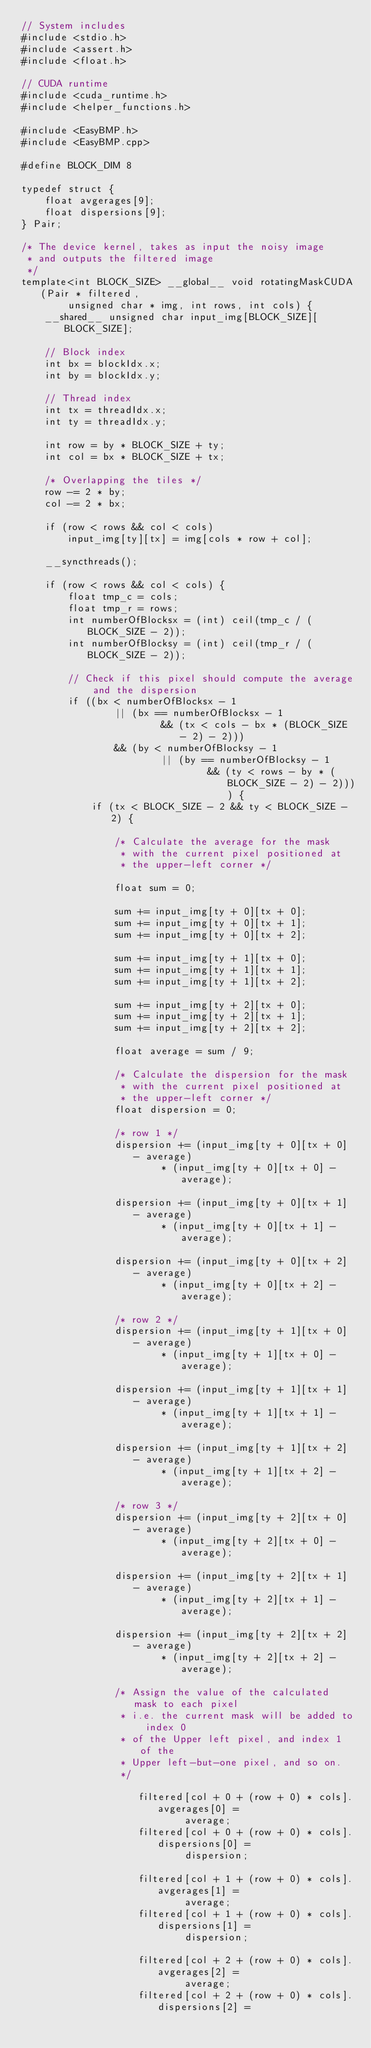<code> <loc_0><loc_0><loc_500><loc_500><_Cuda_>// System includes
#include <stdio.h>
#include <assert.h>
#include <float.h>

// CUDA runtime
#include <cuda_runtime.h>
#include <helper_functions.h>

#include <EasyBMP.h>
#include <EasyBMP.cpp>

#define BLOCK_DIM 8

typedef struct {
	float avgerages[9];
	float dispersions[9];
} Pair;

/* The device kernel, takes as input the noisy image
 * and outputs the filtered image
 */
template<int BLOCK_SIZE> __global__ void rotatingMaskCUDA(Pair * filtered,
		unsigned char * img, int rows, int cols) {
	__shared__ unsigned char input_img[BLOCK_SIZE][BLOCK_SIZE];

	// Block index
	int bx = blockIdx.x;
	int by = blockIdx.y;

	// Thread index
	int tx = threadIdx.x;
	int ty = threadIdx.y;

	int row = by * BLOCK_SIZE + ty;
	int col = bx * BLOCK_SIZE + tx;

	/* Overlapping the tiles */
	row -= 2 * by;
	col -= 2 * bx;

	if (row < rows && col < cols)
		input_img[ty][tx] = img[cols * row + col];

	__syncthreads();

	if (row < rows && col < cols) {
		float tmp_c = cols;
		float tmp_r = rows;
		int numberOfBlocksx = (int) ceil(tmp_c / (BLOCK_SIZE - 2));
		int numberOfBlocksy = (int) ceil(tmp_r / (BLOCK_SIZE - 2));

		// Check if this pixel should compute the average and the dispersion
		if ((bx < numberOfBlocksx - 1
				|| (bx == numberOfBlocksx - 1
						&& (tx < cols - bx * (BLOCK_SIZE - 2) - 2)))
				&& (by < numberOfBlocksy - 1
						|| (by == numberOfBlocksy - 1
								&& (ty < rows - by * (BLOCK_SIZE - 2) - 2)))) {
			if (tx < BLOCK_SIZE - 2 && ty < BLOCK_SIZE - 2) {

				/* Calculate the average for the mask
				 * with the current pixel positioned at
				 * the upper-left corner */

				float sum = 0;

				sum += input_img[ty + 0][tx + 0];
				sum += input_img[ty + 0][tx + 1];
				sum += input_img[ty + 0][tx + 2];

				sum += input_img[ty + 1][tx + 0];
				sum += input_img[ty + 1][tx + 1];
				sum += input_img[ty + 1][tx + 2];

				sum += input_img[ty + 2][tx + 0];
				sum += input_img[ty + 2][tx + 1];
				sum += input_img[ty + 2][tx + 2];

				float average = sum / 9;

				/* Calculate the dispersion for the mask
				 * with the current pixel positioned at
				 * the upper-left corner */
				float dispersion = 0;

				/* row 1 */
				dispersion += (input_img[ty + 0][tx + 0] - average)
						* (input_img[ty + 0][tx + 0] - average);

				dispersion += (input_img[ty + 0][tx + 1] - average)
						* (input_img[ty + 0][tx + 1] - average);

				dispersion += (input_img[ty + 0][tx + 2] - average)
						* (input_img[ty + 0][tx + 2] - average);

				/* row 2 */
				dispersion += (input_img[ty + 1][tx + 0] - average)
						* (input_img[ty + 1][tx + 0] - average);

				dispersion += (input_img[ty + 1][tx + 1] - average)
						* (input_img[ty + 1][tx + 1] - average);

				dispersion += (input_img[ty + 1][tx + 2] - average)
						* (input_img[ty + 1][tx + 2] - average);

				/* row 3 */
				dispersion += (input_img[ty + 2][tx + 0] - average)
						* (input_img[ty + 2][tx + 0] - average);

				dispersion += (input_img[ty + 2][tx + 1] - average)
						* (input_img[ty + 2][tx + 1] - average);

				dispersion += (input_img[ty + 2][tx + 2] - average)
						* (input_img[ty + 2][tx + 2] - average);

				/* Assign the value of the calculated mask to each pixel
				 * i.e. the current mask will be added to index 0
				 * of the Upper left pixel, and index 1 of the
				 * Upper left-but-one pixel, and so on.
				 */

					filtered[col + 0 + (row + 0) * cols].avgerages[0] =
							average;
					filtered[col + 0 + (row + 0) * cols].dispersions[0] =
							dispersion;

					filtered[col + 1 + (row + 0) * cols].avgerages[1] =
							average;
					filtered[col + 1 + (row + 0) * cols].dispersions[1] =
							dispersion;

					filtered[col + 2 + (row + 0) * cols].avgerages[2] =
							average;
					filtered[col + 2 + (row + 0) * cols].dispersions[2] =</code> 